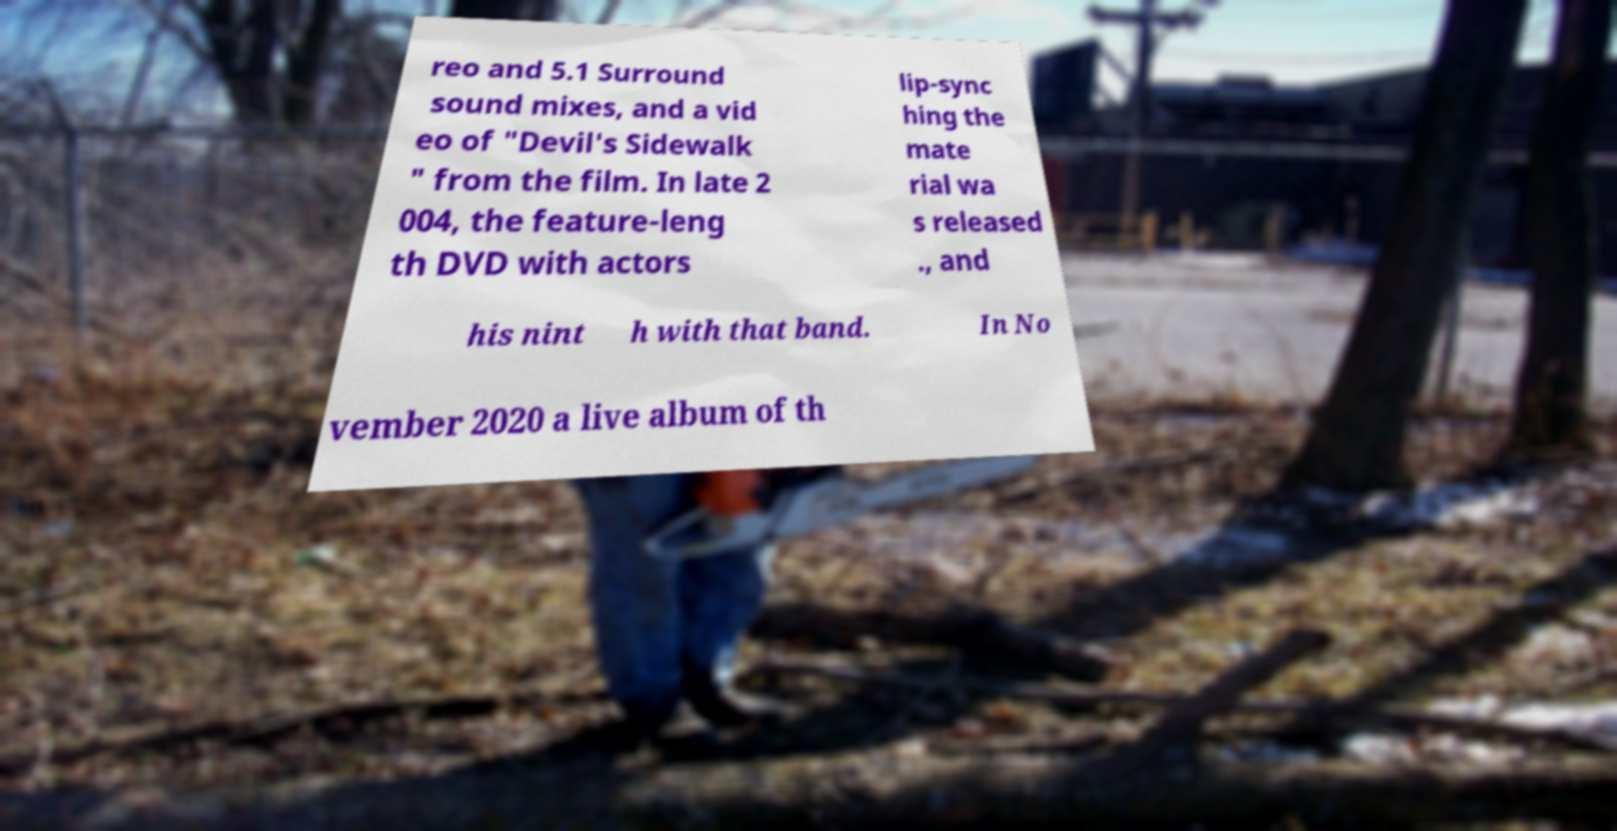I need the written content from this picture converted into text. Can you do that? reo and 5.1 Surround sound mixes, and a vid eo of "Devil's Sidewalk " from the film. In late 2 004, the feature-leng th DVD with actors lip-sync hing the mate rial wa s released ., and his nint h with that band. In No vember 2020 a live album of th 